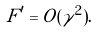Convert formula to latex. <formula><loc_0><loc_0><loc_500><loc_500>F ^ { \prime } = O ( { \gamma } ^ { 2 } ) .</formula> 